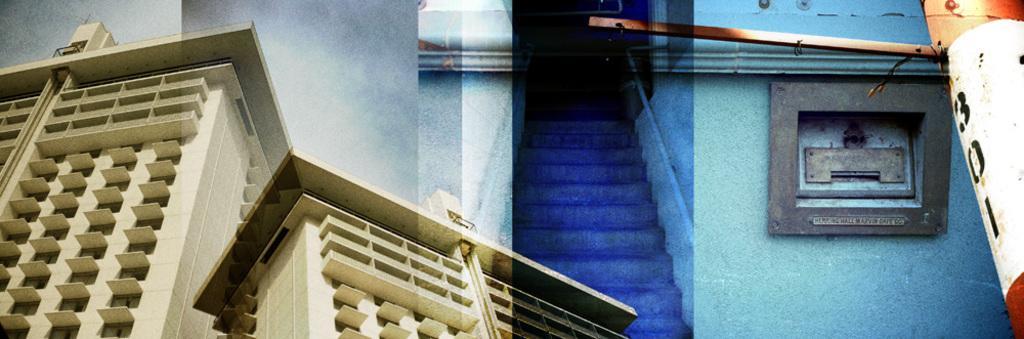How would you summarize this image in a sentence or two? It is an edited image. In the center of the image there are stairs. On the left side of the image there are buildings. On the right side of the image there is a pole and we can see some object attached to the wall. 